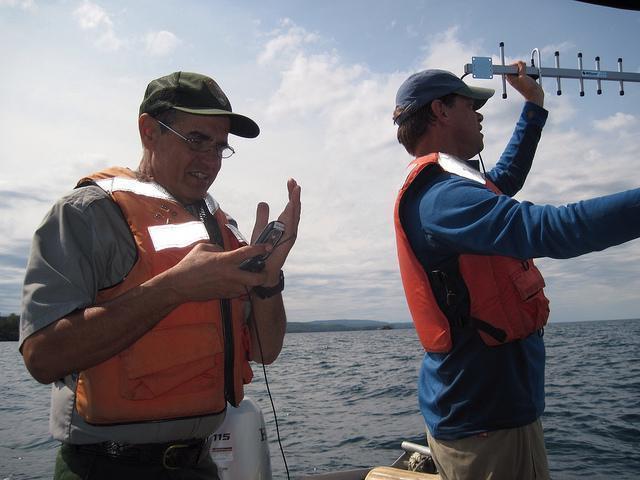How many people are in the photo?
Give a very brief answer. 2. How many giraffes are standing up?
Give a very brief answer. 0. 